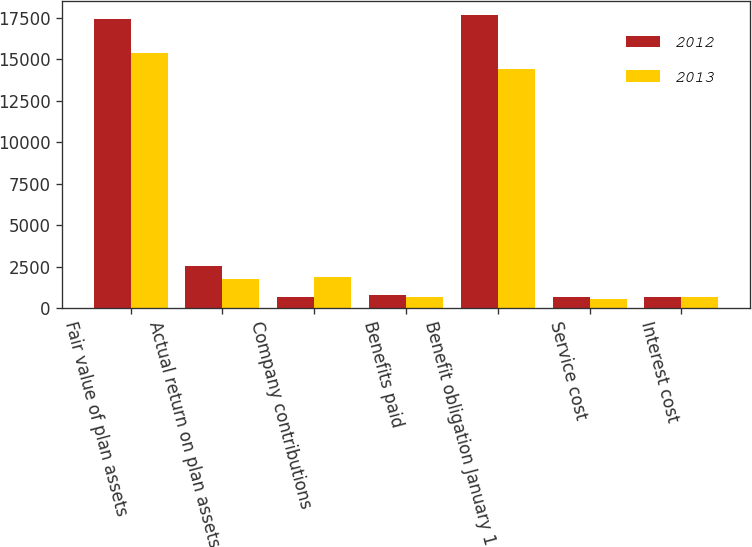Convert chart. <chart><loc_0><loc_0><loc_500><loc_500><stacked_bar_chart><ecel><fcel>Fair value of plan assets<fcel>Actual return on plan assets<fcel>Company contributions<fcel>Benefits paid<fcel>Benefit obligation January 1<fcel>Service cost<fcel>Interest cost<nl><fcel>2012<fcel>17435<fcel>2524<fcel>645<fcel>780<fcel>17646<fcel>682<fcel>665<nl><fcel>2013<fcel>15349<fcel>1739<fcel>1853<fcel>673<fcel>14416<fcel>555<fcel>661<nl></chart> 